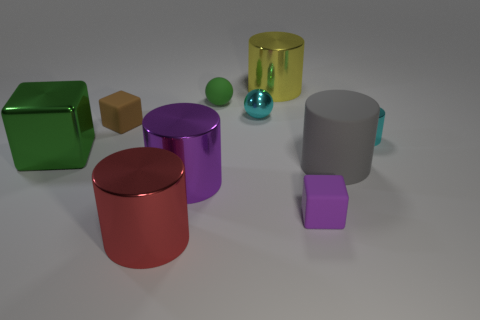Subtract all cyan cylinders. How many cylinders are left? 4 Subtract all large matte cylinders. How many cylinders are left? 4 Subtract all yellow cylinders. Subtract all blue cubes. How many cylinders are left? 4 Subtract all spheres. How many objects are left? 8 Subtract all small cyan metal spheres. Subtract all purple blocks. How many objects are left? 8 Add 2 cyan things. How many cyan things are left? 4 Add 7 yellow metallic objects. How many yellow metallic objects exist? 8 Subtract 1 purple cubes. How many objects are left? 9 